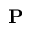Convert formula to latex. <formula><loc_0><loc_0><loc_500><loc_500>{ P }</formula> 